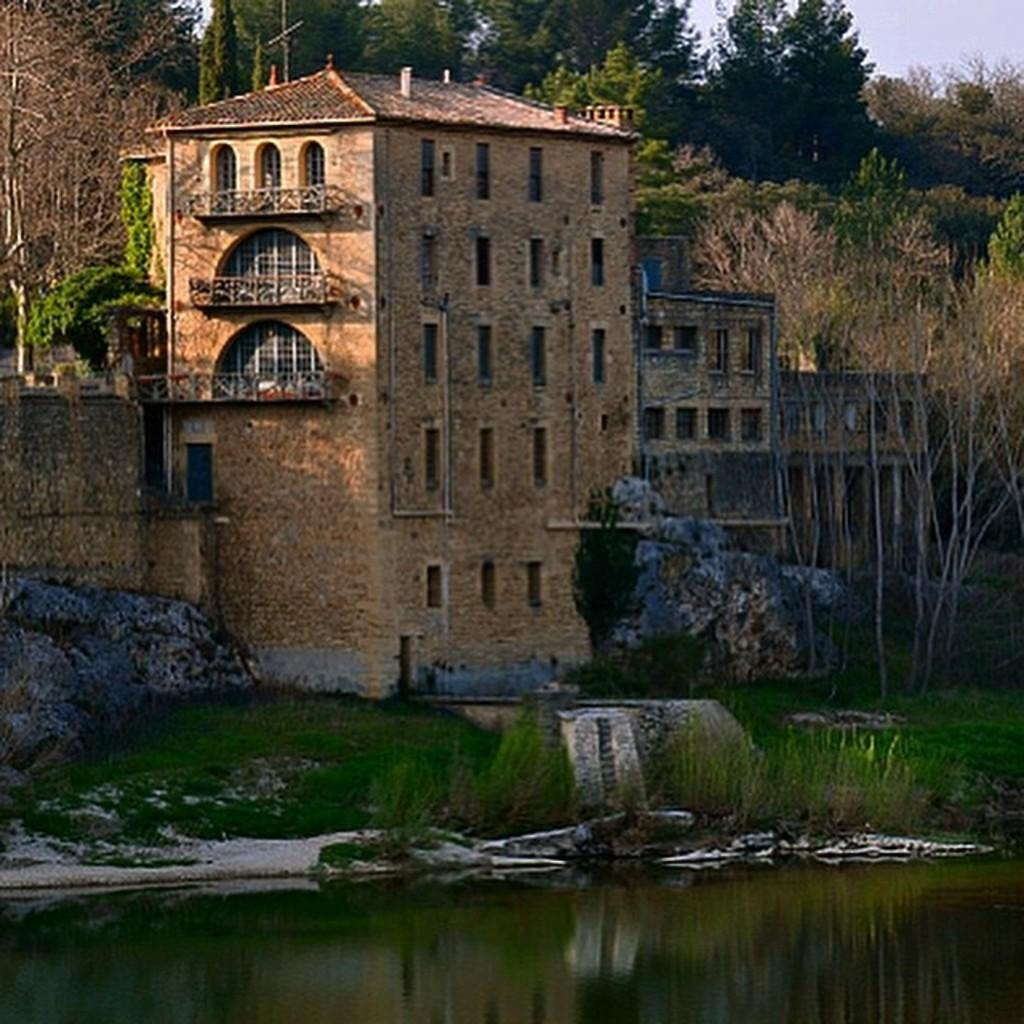What is visible in the image? Water, grass, rocks, a building, trees, and the sky are visible in the image. Can you describe the area in front of the water? There is grass in front of the water. What can be seen in the background of the image? There is a building, trees, and the sky visible in the background of the image. Are there any natural elements present in the image? Yes, there are rocks in the image. What type of religious ceremony is taking place near the water in the image? There is no indication of a religious ceremony or any religious elements in the image. How many horses are present in the image? There are no horses present in the image. 